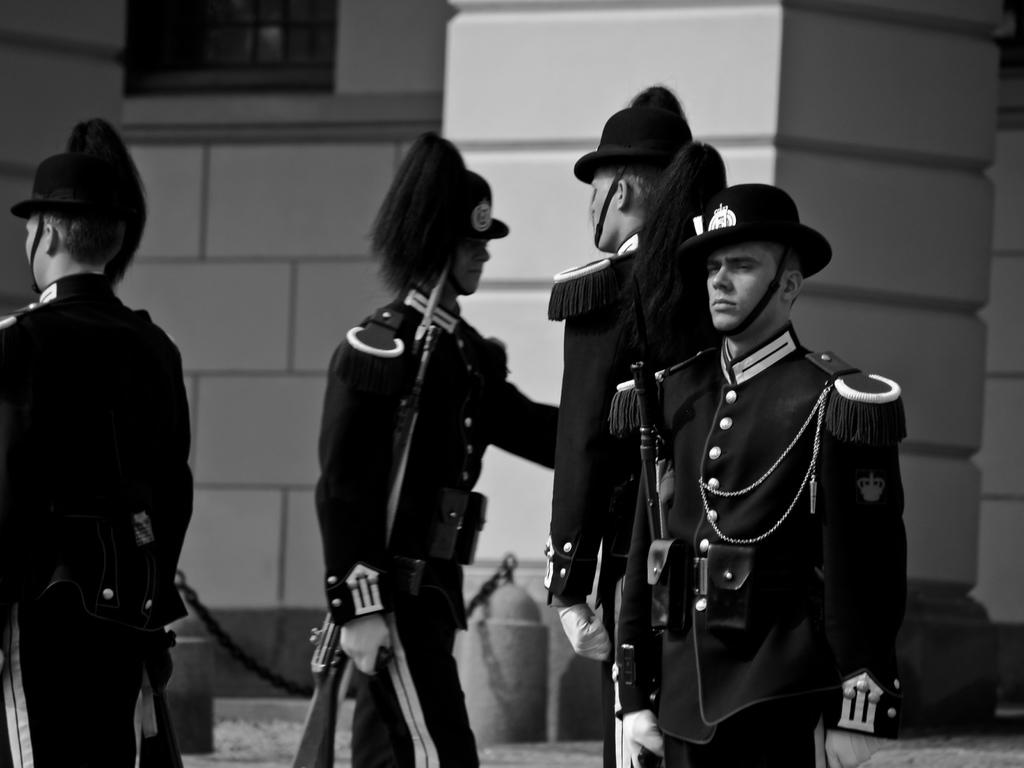How many people are in the image? There are four persons in the image. What are the four persons wearing? The four persons are wearing the same dress. What are the persons holding in their hands? The persons are holding guns. What can be seen in the background of the image? There is a building in the background of the image. Where is the window located in the image? There is a window at the top left of the image. What type of goat can be seen interacting with the persons in the image? There is no goat present in the image; the persons are holding guns and there are no animals visible. What is the purpose of the crook in the image? There is no crook present in the image; it is a group of people holding guns and there is no mention of a crook or any related object. 